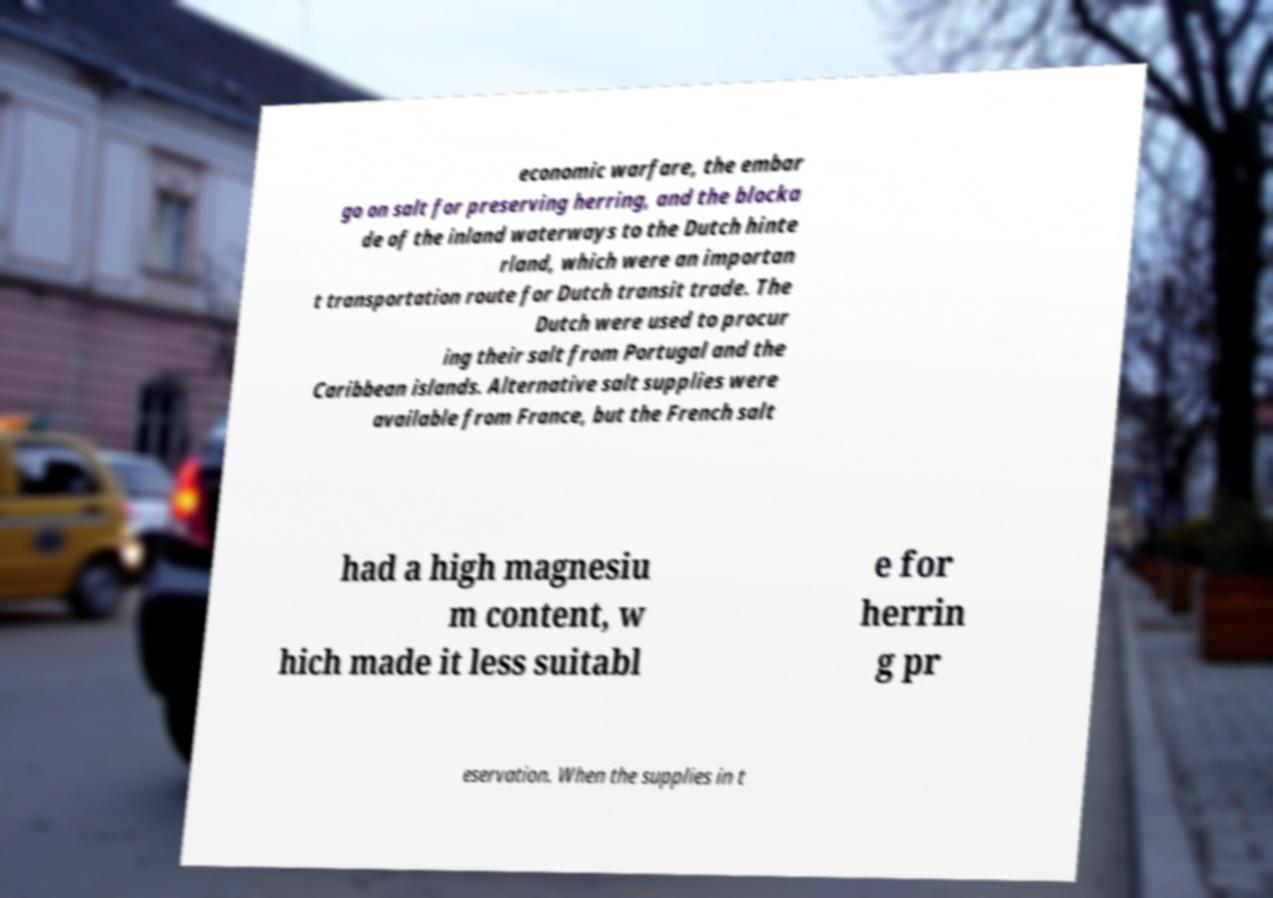Please identify and transcribe the text found in this image. economic warfare, the embar go on salt for preserving herring, and the blocka de of the inland waterways to the Dutch hinte rland, which were an importan t transportation route for Dutch transit trade. The Dutch were used to procur ing their salt from Portugal and the Caribbean islands. Alternative salt supplies were available from France, but the French salt had a high magnesiu m content, w hich made it less suitabl e for herrin g pr eservation. When the supplies in t 